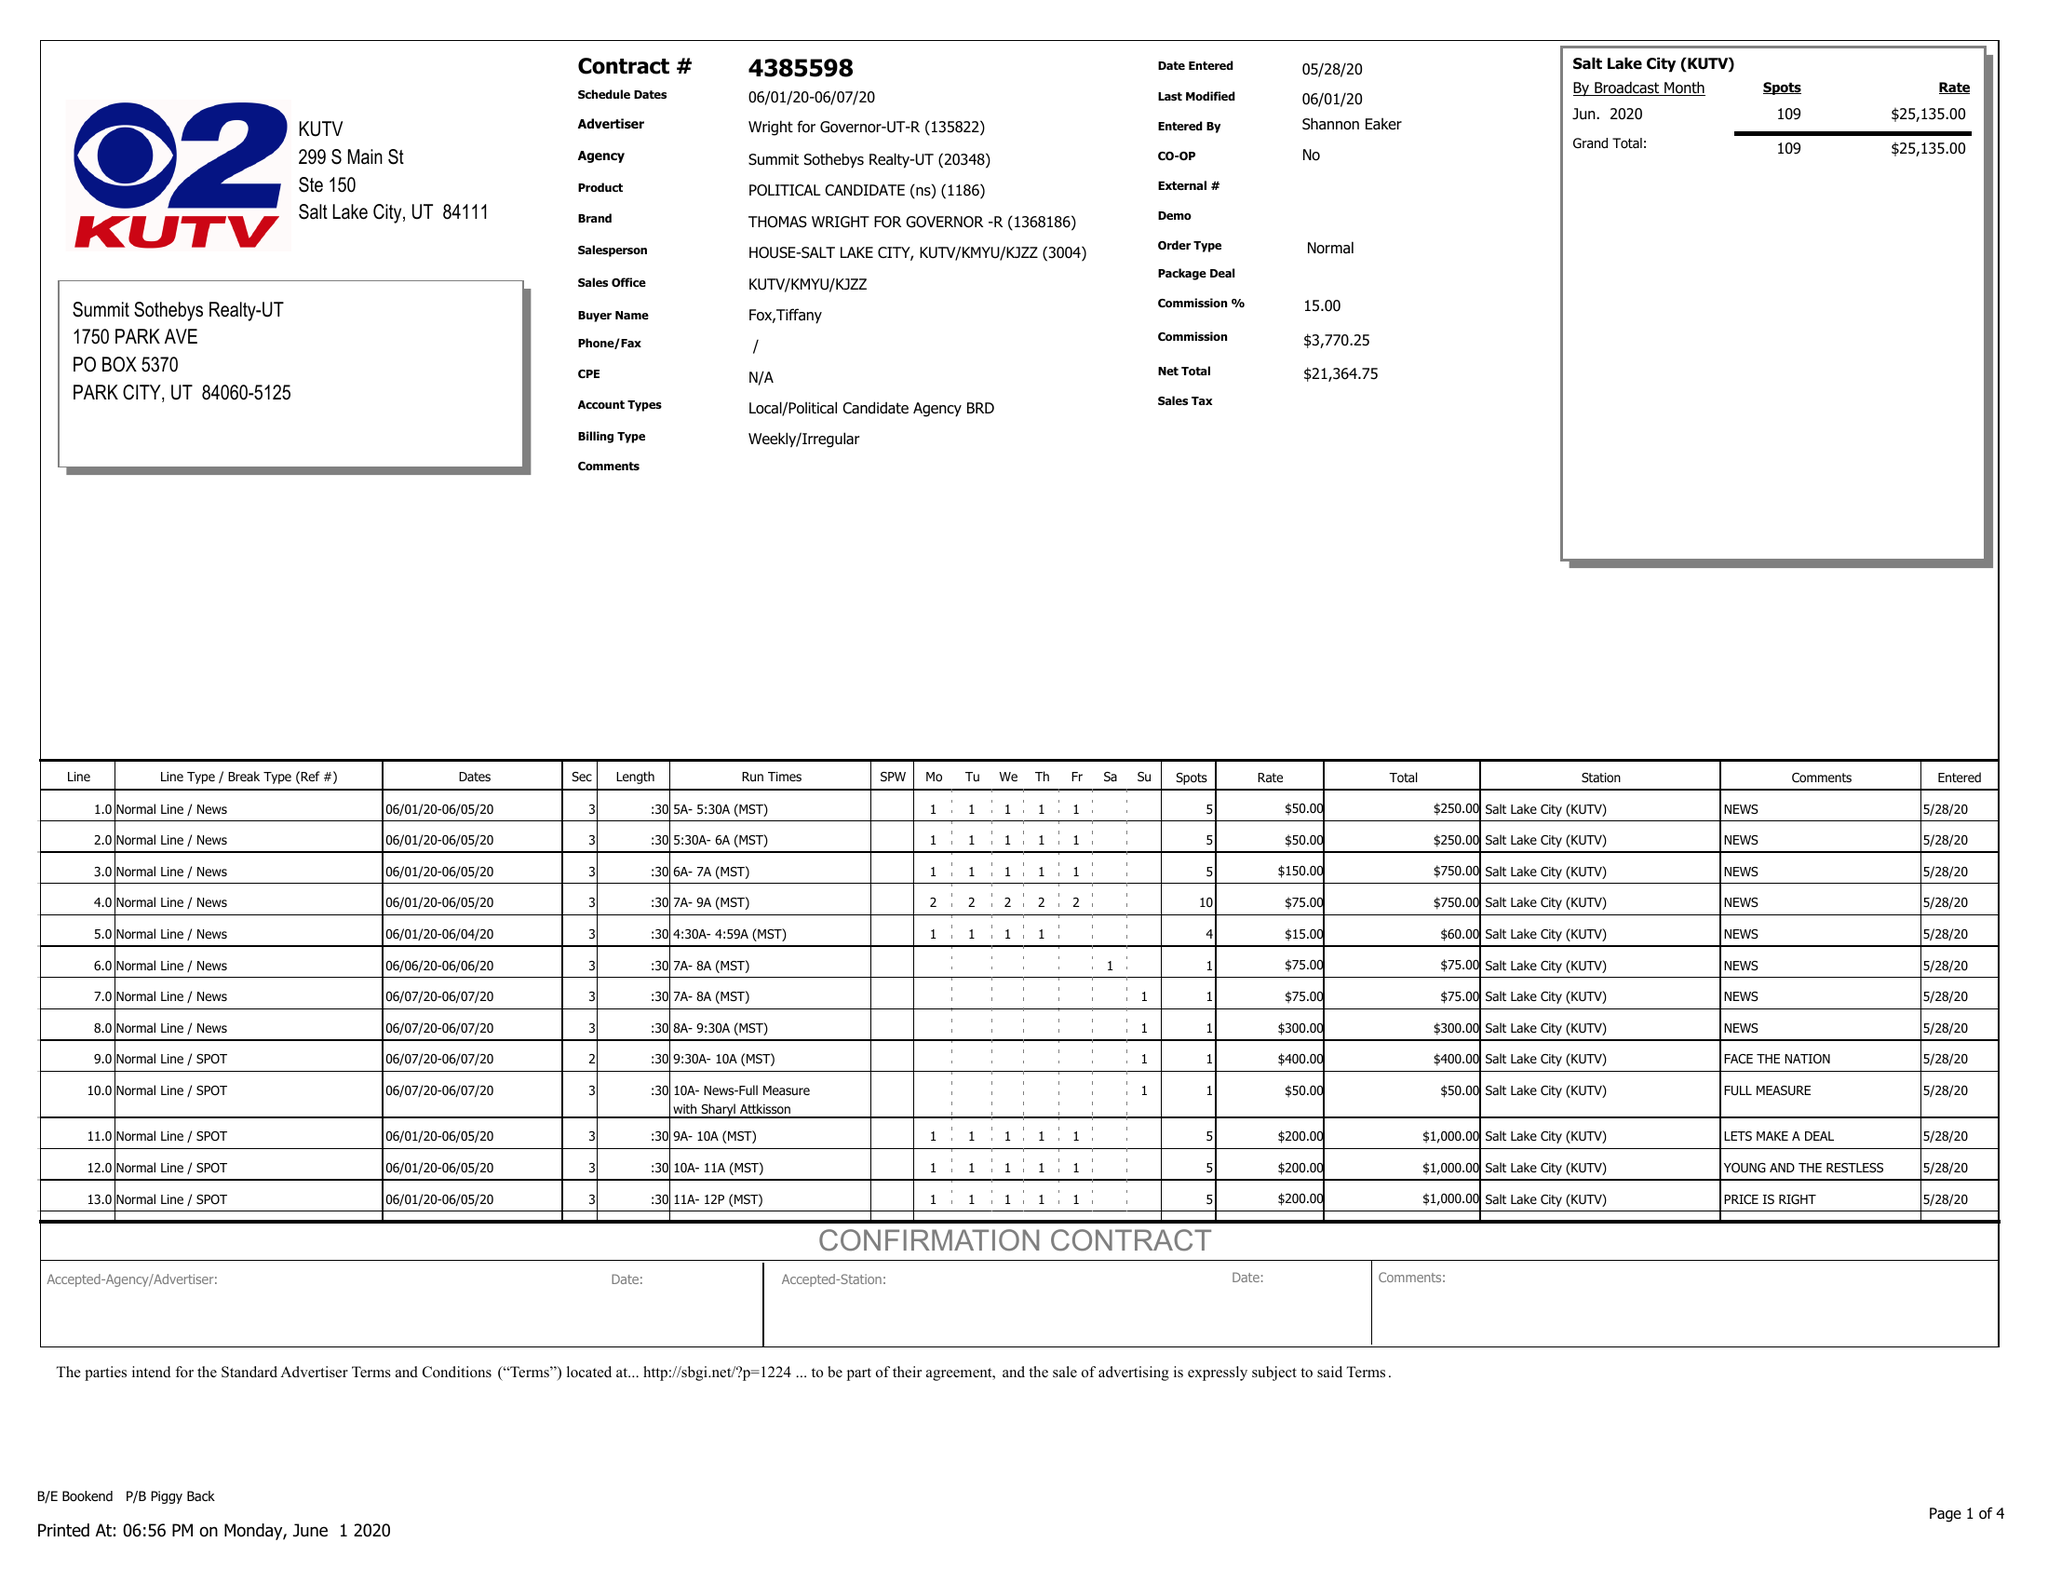What is the value for the flight_from?
Answer the question using a single word or phrase. 06/01/20 